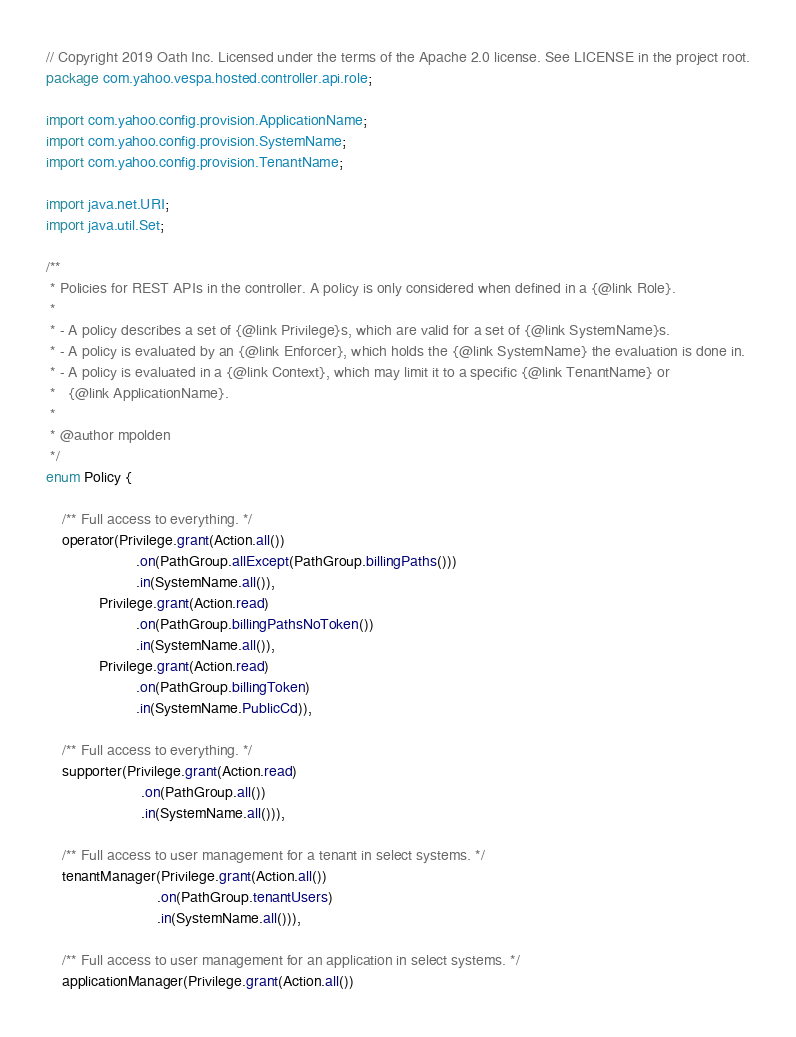Convert code to text. <code><loc_0><loc_0><loc_500><loc_500><_Java_>// Copyright 2019 Oath Inc. Licensed under the terms of the Apache 2.0 license. See LICENSE in the project root.
package com.yahoo.vespa.hosted.controller.api.role;

import com.yahoo.config.provision.ApplicationName;
import com.yahoo.config.provision.SystemName;
import com.yahoo.config.provision.TenantName;

import java.net.URI;
import java.util.Set;

/**
 * Policies for REST APIs in the controller. A policy is only considered when defined in a {@link Role}.
 *
 * - A policy describes a set of {@link Privilege}s, which are valid for a set of {@link SystemName}s.
 * - A policy is evaluated by an {@link Enforcer}, which holds the {@link SystemName} the evaluation is done in.
 * - A policy is evaluated in a {@link Context}, which may limit it to a specific {@link TenantName} or
 *   {@link ApplicationName}.
 *
 * @author mpolden
 */
enum Policy {

    /** Full access to everything. */
    operator(Privilege.grant(Action.all())
                      .on(PathGroup.allExcept(PathGroup.billingPaths()))
                      .in(SystemName.all()),
             Privilege.grant(Action.read)
                      .on(PathGroup.billingPathsNoToken())
                      .in(SystemName.all()),
             Privilege.grant(Action.read)
                      .on(PathGroup.billingToken)
                      .in(SystemName.PublicCd)),

    /** Full access to everything. */
    supporter(Privilege.grant(Action.read)
                       .on(PathGroup.all())
                       .in(SystemName.all())),

    /** Full access to user management for a tenant in select systems. */
    tenantManager(Privilege.grant(Action.all())
                           .on(PathGroup.tenantUsers)
                           .in(SystemName.all())),

    /** Full access to user management for an application in select systems. */
    applicationManager(Privilege.grant(Action.all())</code> 